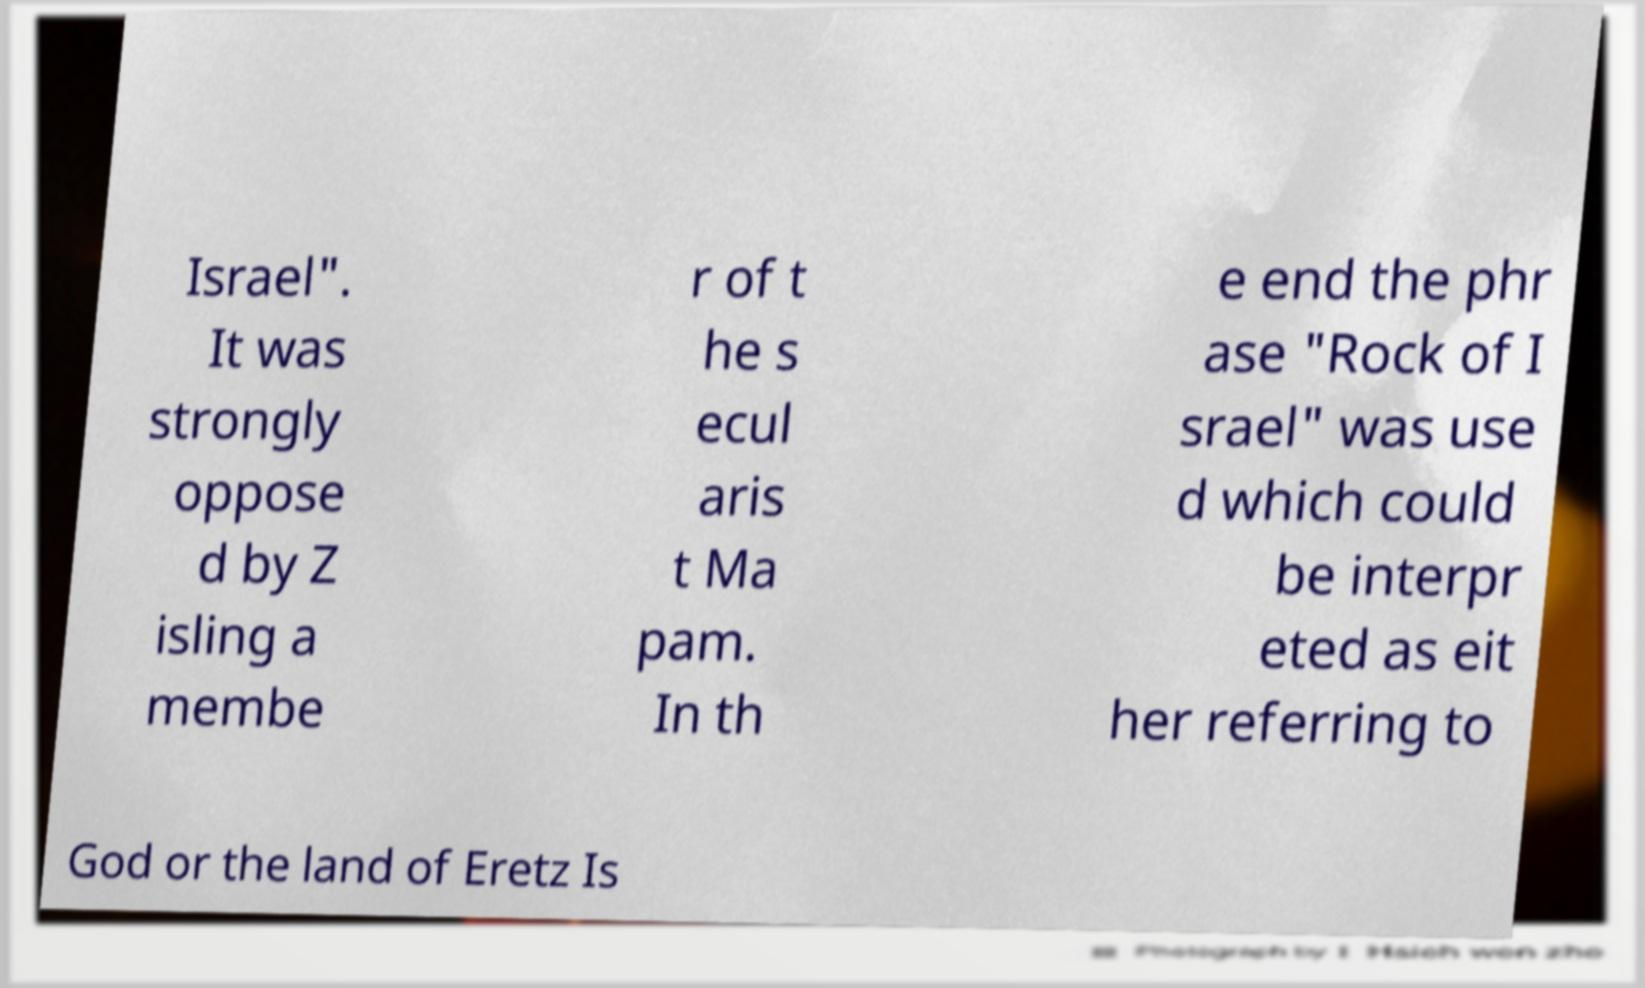What messages or text are displayed in this image? I need them in a readable, typed format. Israel". It was strongly oppose d by Z isling a membe r of t he s ecul aris t Ma pam. In th e end the phr ase "Rock of I srael" was use d which could be interpr eted as eit her referring to God or the land of Eretz Is 